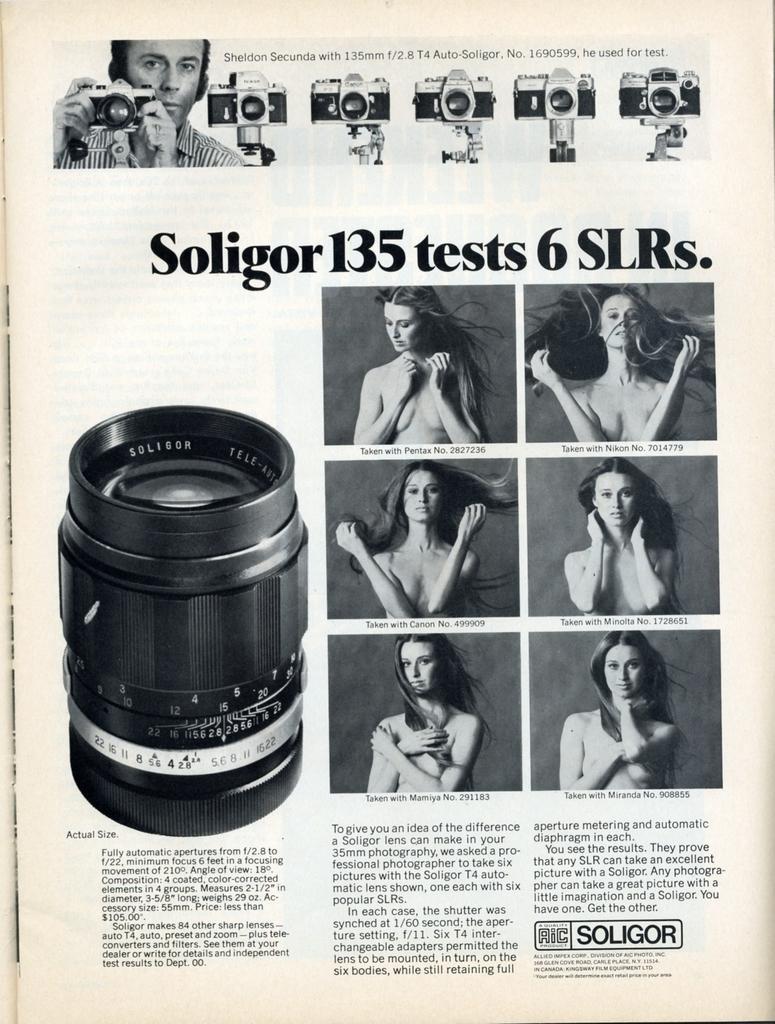Could you give a brief overview of what you see in this image? This image consists of a paper with a few images of a woman, a camera and a man and there is a text on it. 